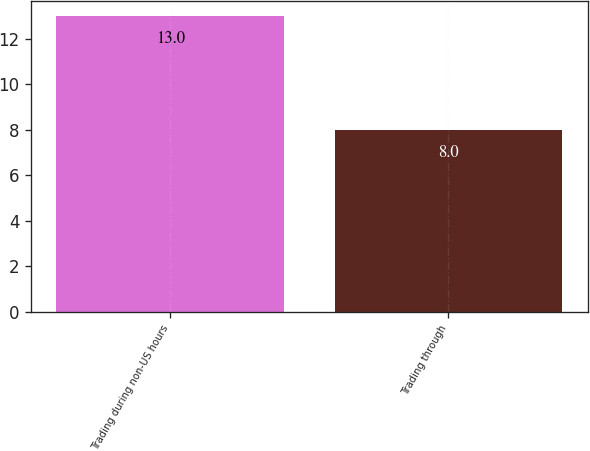Convert chart to OTSL. <chart><loc_0><loc_0><loc_500><loc_500><bar_chart><fcel>Trading during non-US hours<fcel>Trading through<nl><fcel>13<fcel>8<nl></chart> 